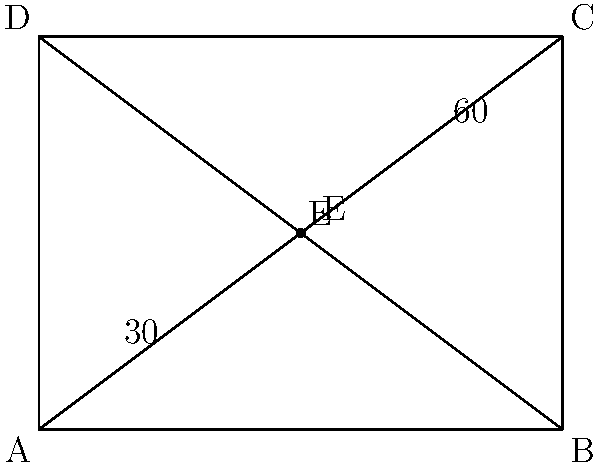In a home network setup, Ethernet cables are running through walls, forming intersections as shown in the diagram. Given that angle AEC is 60° and angle AEB is 30°, what is the measure of angle BEC? Let's approach this step-by-step:

1) First, recall that the sum of angles in a triangle is always 180°.

2) In triangle AEC:
   $\angle AEC + \angle CAE + \angle AEC = 180°$

3) We're given that $\angle AEC = 60°$. Let's call $\angle CAE = x$. So:
   $60° + x + 30° = 180°$

4) Simplify:
   $90° + x = 180°$
   $x = 90°$

5) So, $\angle CAE = 90°$

6) Now, in triangle BEC:
   $\angle BEC + \angle CBE + \angle BCE = 180°$

7) We know $\angle CBE = 90°$ (it's the same as $\angle CAE$), and we're looking for $\angle BEC$. Let's call it $y$:
   $y + 90° + 30° = 180°$

8) Simplify:
   $y + 120° = 180°$
   $y = 60°$

Therefore, $\angle BEC = 60°$.
Answer: 60° 